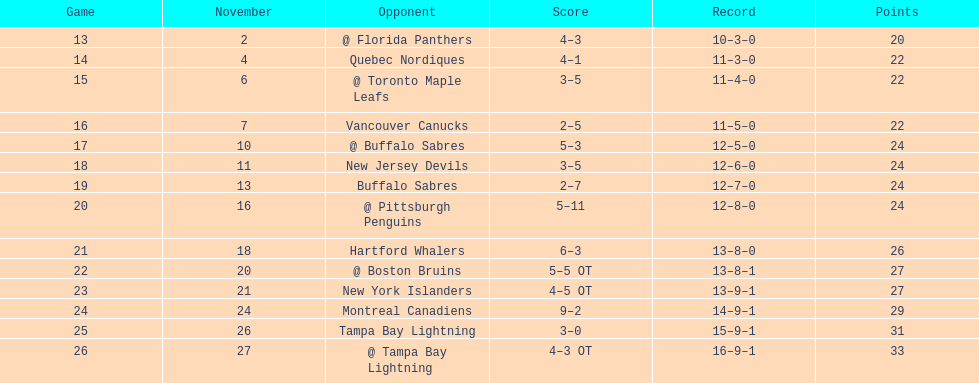Which other team had a similar number of victories? New York Islanders. 